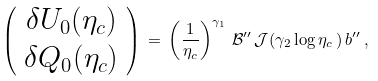<formula> <loc_0><loc_0><loc_500><loc_500>\left ( \begin{array} { c } \delta U _ { 0 } ( \eta _ { c } ) \\ \delta Q _ { 0 } ( \eta _ { c } ) \end{array} \right ) \, = \, \left ( \frac { 1 } { \eta _ { c } } \right ) ^ { \gamma _ { 1 } } \, { \mathcal { B } } ^ { \prime \prime } \, { \mathcal { J } } ( \gamma _ { 2 } \log \eta _ { c } \, ) \, b ^ { \prime \prime } \, ,</formula> 